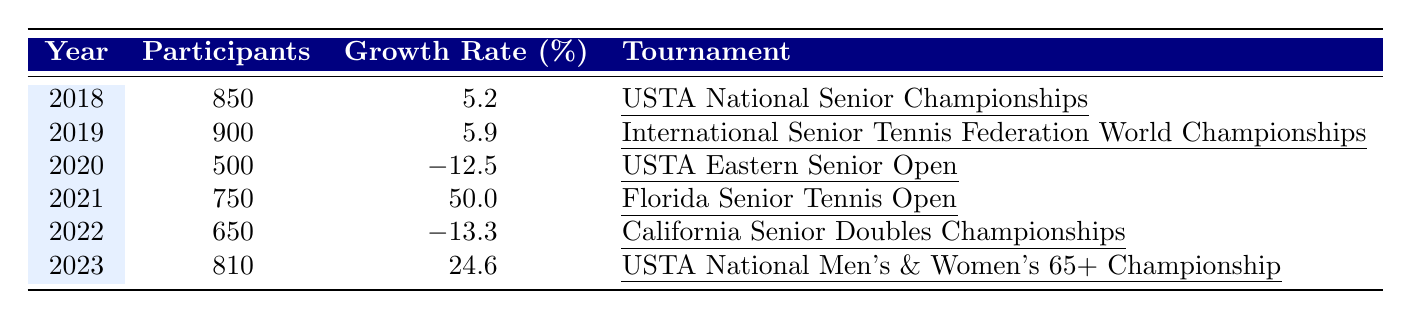What was the participation rate in the USTA National Senior Championships in 2018? According to the table, the number of participants in the USTA National Senior Championships in 2018 was 850.
Answer: 850 Which tournament had the highest participation in 2019? The table indicates that the International Senior Tennis Federation World Championships had the highest participation in 2019 with 900 participants.
Answer: 900 What was the growth rate for the USTA Eastern Senior Open in 2020? The table shows that the growth rate for the USTA Eastern Senior Open in 2020 was -12.5%.
Answer: -12.5% What was the average number of participants across all tournaments from 2018 to 2023? The total participants from 2018 to 2023 are 850 + 900 + 500 + 750 + 650 + 810 = 3960. There are 6 years, so the average is 3960/6 = 660.
Answer: 660 Did the Florida Senior Tennis Open in 2021 experience a growth rate higher than 25%? The growth rate for the Florida Senior Tennis Open in 2021 was 50.0%, which is higher than 25%. Therefore, the answer is yes.
Answer: Yes What is the difference in participants between the years 2019 and 2021? In 2019, there were 900 participants and in 2021, there were 750 participants. The difference is 900 - 750 = 150.
Answer: 150 Which tournament had the lowest number of participants and what was the figure? The USTA Eastern Senior Open in 2020 had the lowest number of participants, recorded at 500.
Answer: 500 Calculate the total growth rate across all tournaments from 2018 to 2023. The total growth rate is calculated by summing the growth rates: 5.2 + 5.9 - 12.5 + 50.0 - 13.3 + 24.6 = 60.9%.
Answer: 60.9% Was there a year where the growth rate was negative, and if so, which year(s)? Yes, the years with negative growth rates were 2020 (-12.5%) and 2022 (-13.3%).
Answer: Yes, 2020 and 2022 How many participants were there in the California Senior Doubles Championships compared to the USTA National Men's & Women's 65+ Championship? The California Senior Doubles Championships had 650 participants, while the USTA National Men's & Women's 65+ Championship had 810 participants. Thus, there were 810 - 650 = 160 more participants in the latter.
Answer: 160 